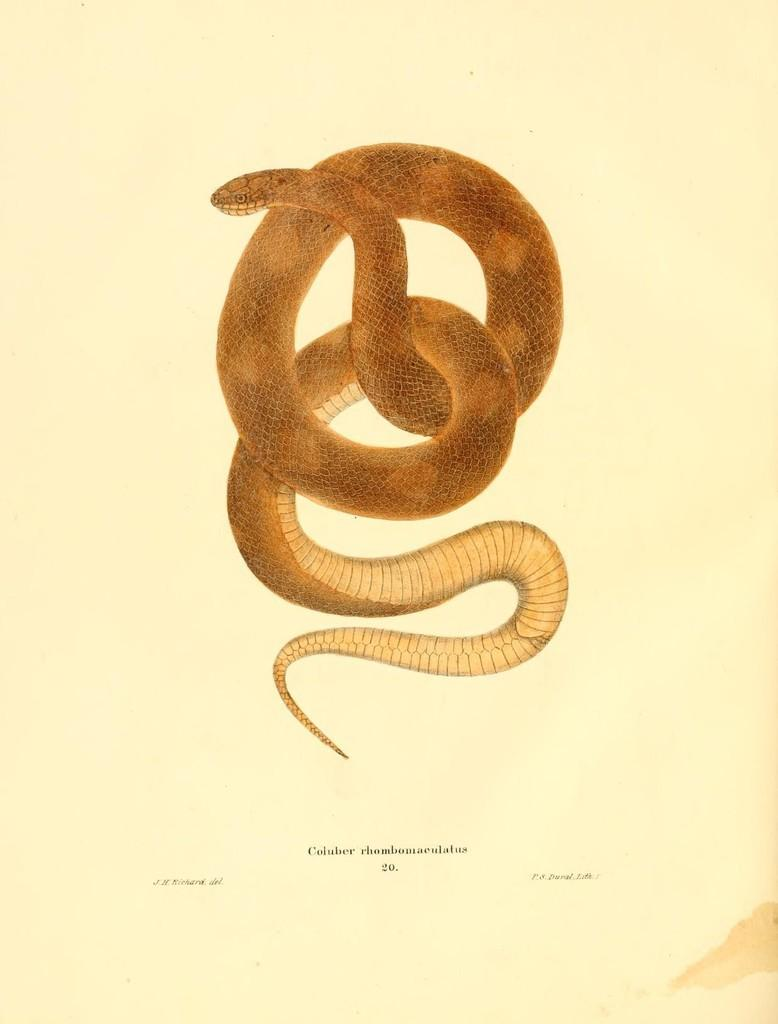What is the main subject in the center of the image? There is a paper in the center of the image. What is depicted on the paper? There is a snake drawing on the paper. What color is the snake drawing? The snake drawing is in brown color. Are there any words or letters on the paper? Yes, there is writing on the paper. What type of oatmeal is being served in the image? There is no oatmeal present in the image; it features a paper with a snake drawing and writing. 